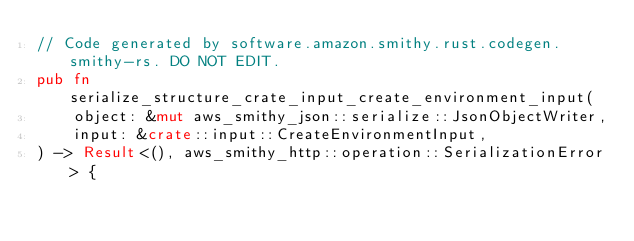Convert code to text. <code><loc_0><loc_0><loc_500><loc_500><_Rust_>// Code generated by software.amazon.smithy.rust.codegen.smithy-rs. DO NOT EDIT.
pub fn serialize_structure_crate_input_create_environment_input(
    object: &mut aws_smithy_json::serialize::JsonObjectWriter,
    input: &crate::input::CreateEnvironmentInput,
) -> Result<(), aws_smithy_http::operation::SerializationError> {</code> 